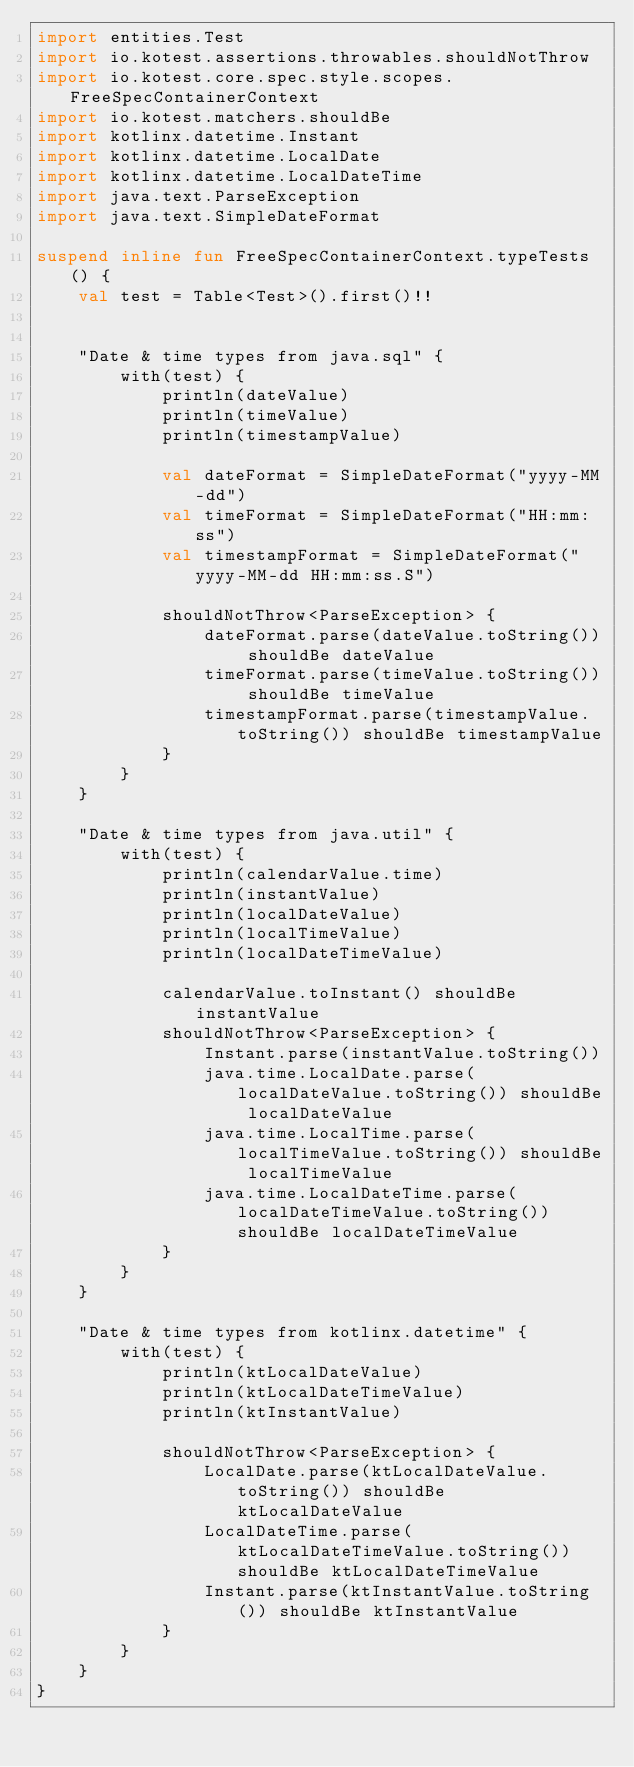<code> <loc_0><loc_0><loc_500><loc_500><_Kotlin_>import entities.Test
import io.kotest.assertions.throwables.shouldNotThrow
import io.kotest.core.spec.style.scopes.FreeSpecContainerContext
import io.kotest.matchers.shouldBe
import kotlinx.datetime.Instant
import kotlinx.datetime.LocalDate
import kotlinx.datetime.LocalDateTime
import java.text.ParseException
import java.text.SimpleDateFormat

suspend inline fun FreeSpecContainerContext.typeTests() {
    val test = Table<Test>().first()!!


    "Date & time types from java.sql" {
        with(test) {
            println(dateValue)
            println(timeValue)
            println(timestampValue)

            val dateFormat = SimpleDateFormat("yyyy-MM-dd")
            val timeFormat = SimpleDateFormat("HH:mm:ss")
            val timestampFormat = SimpleDateFormat("yyyy-MM-dd HH:mm:ss.S")

            shouldNotThrow<ParseException> {
                dateFormat.parse(dateValue.toString()) shouldBe dateValue
                timeFormat.parse(timeValue.toString()) shouldBe timeValue
                timestampFormat.parse(timestampValue.toString()) shouldBe timestampValue
            }
        }
    }

    "Date & time types from java.util" {
        with(test) {
            println(calendarValue.time)
            println(instantValue)
            println(localDateValue)
            println(localTimeValue)
            println(localDateTimeValue)

            calendarValue.toInstant() shouldBe instantValue
            shouldNotThrow<ParseException> {
                Instant.parse(instantValue.toString())
                java.time.LocalDate.parse(localDateValue.toString()) shouldBe localDateValue
                java.time.LocalTime.parse(localTimeValue.toString()) shouldBe localTimeValue
                java.time.LocalDateTime.parse(localDateTimeValue.toString()) shouldBe localDateTimeValue
            }
        }
    }

    "Date & time types from kotlinx.datetime" {
        with(test) {
            println(ktLocalDateValue)
            println(ktLocalDateTimeValue)
            println(ktInstantValue)

            shouldNotThrow<ParseException> {
                LocalDate.parse(ktLocalDateValue.toString()) shouldBe ktLocalDateValue
                LocalDateTime.parse(ktLocalDateTimeValue.toString()) shouldBe ktLocalDateTimeValue
                Instant.parse(ktInstantValue.toString()) shouldBe ktInstantValue
            }
        }
    }
}</code> 